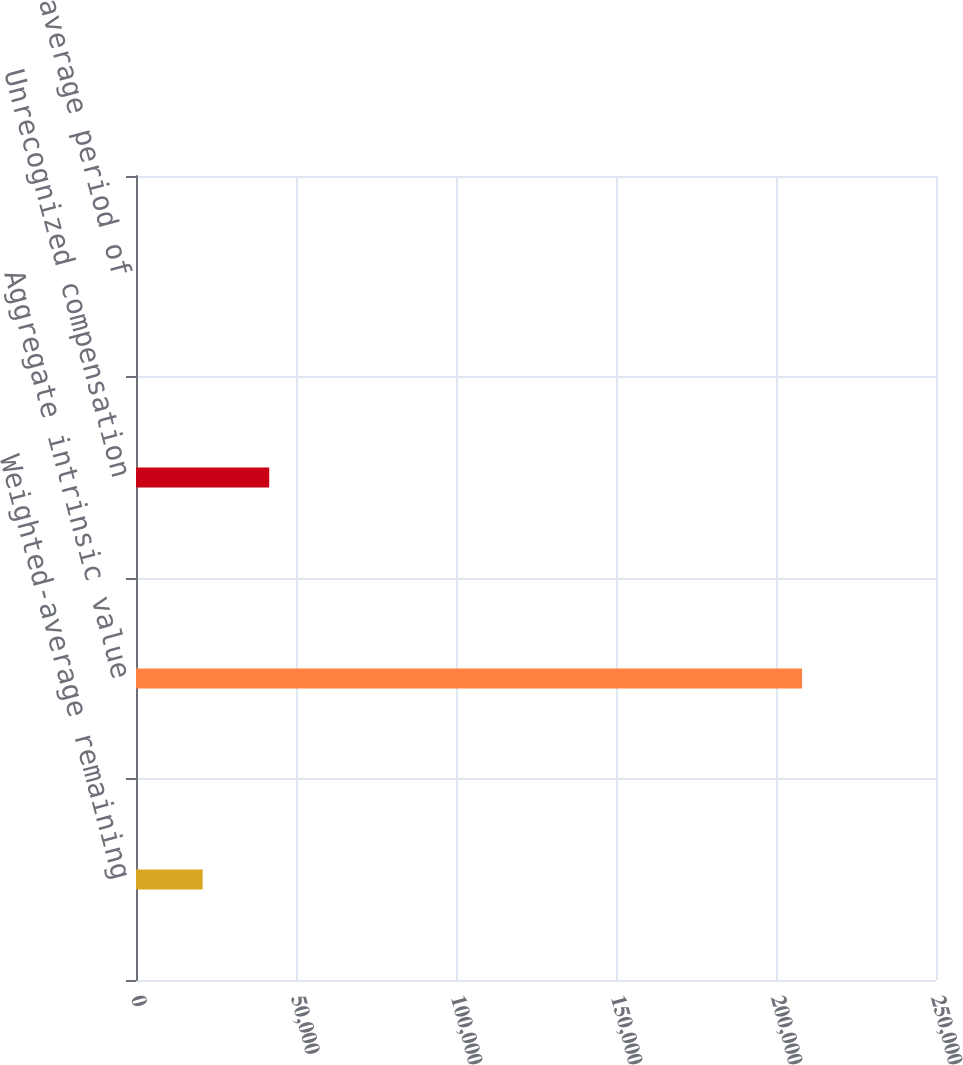Convert chart to OTSL. <chart><loc_0><loc_0><loc_500><loc_500><bar_chart><fcel>Weighted-average remaining<fcel>Aggregate intrinsic value<fcel>Unrecognized compensation<fcel>Weighted average period of<nl><fcel>20816.1<fcel>208152<fcel>41631.2<fcel>0.96<nl></chart> 